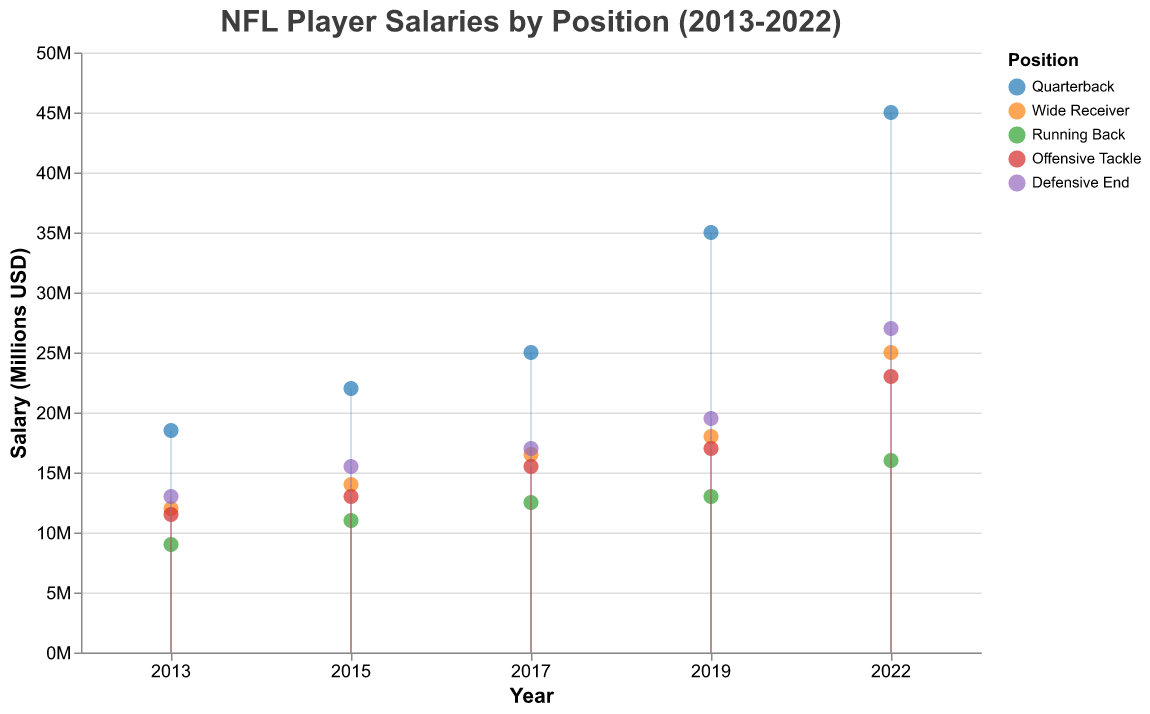What is the title of the figure? The title of the figure is displayed at the top in a larger font size.
Answer: NFL Player Salaries by Position (2013-2022) How many different positions are represented in the plot? By observing the legend on the right side of the figure, we can count the number of unique positions listed.
Answer: 5 Which position had the highest salary in 2022? Look at the year 2022 on the x-axis and identify the highest point on the y-axis, then check the color and refer to the legend to identify the position.
Answer: Quarterback What is the salary difference between Quarterbacks and Running Backs in 2019? Find the 2019 data points for Quarterbacks and Running Backs on the x-axis and note their y-axis values. Subtract the Running Back salary from the Quarterback salary.
Answer: 22000000 Which position showed the most significant increase in salary from 2013 to 2022? Compare the salary values at the beginning (2013) and end (2022) for each position. Calculate the difference and determine which position has the highest increase.
Answer: Quarterback What is the average salary for Wide Receivers over the decade? Sum the salary values for Wide Receivers from 2013 to 2022 and divide by the number of data points (5).
Answer: 17100000 How does the 2017 salary of Offensive Tackles compare to the 2017 salary of Defensive Ends? Locate the 2017 data points for both Offensive Tackles and Defensive Ends on the x-axis and compare their y-axis values directly.
Answer: Defensive Ends have higher salaries What is the overall trend in player salaries from 2013 to 2022? Analyze the general pattern of the data points over time for all positions. Note whether the points move upward, downward, or remain relatively stable.
Answer: Increasing trend Which position had the least variation in salaries over the decade? Examine the spread of data points for each position and see which has the smallest range between the highest and lowest values.
Answer: Running Back Are there any years where the salaries of Wide Receivers and Offensive Tackles are roughly equal? Compare the data points for Wide Receivers and Offensive Tackles year by year to check for any overlap or proximity.
Answer: 2015 